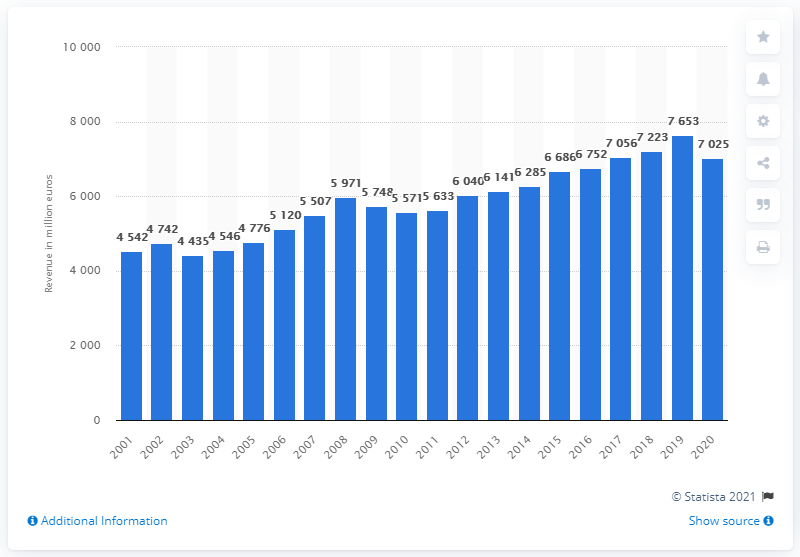List a handful of essential elements in this visual. The revenue of Beiersdorf in 2020 was 7,025. 